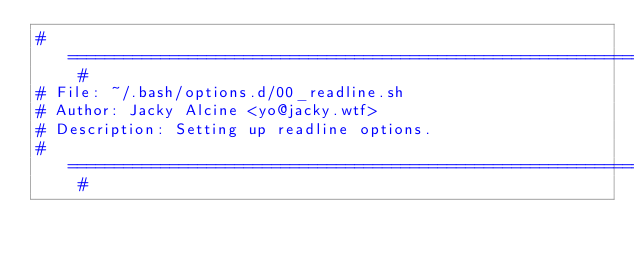<code> <loc_0><loc_0><loc_500><loc_500><_Bash_># =========================================================================== #
# File: ~/.bash/options.d/00_readline.sh
# Author: Jacky Alcine <yo@jacky.wtf>
# Description: Setting up readline options.
# =========================================================================== #
</code> 